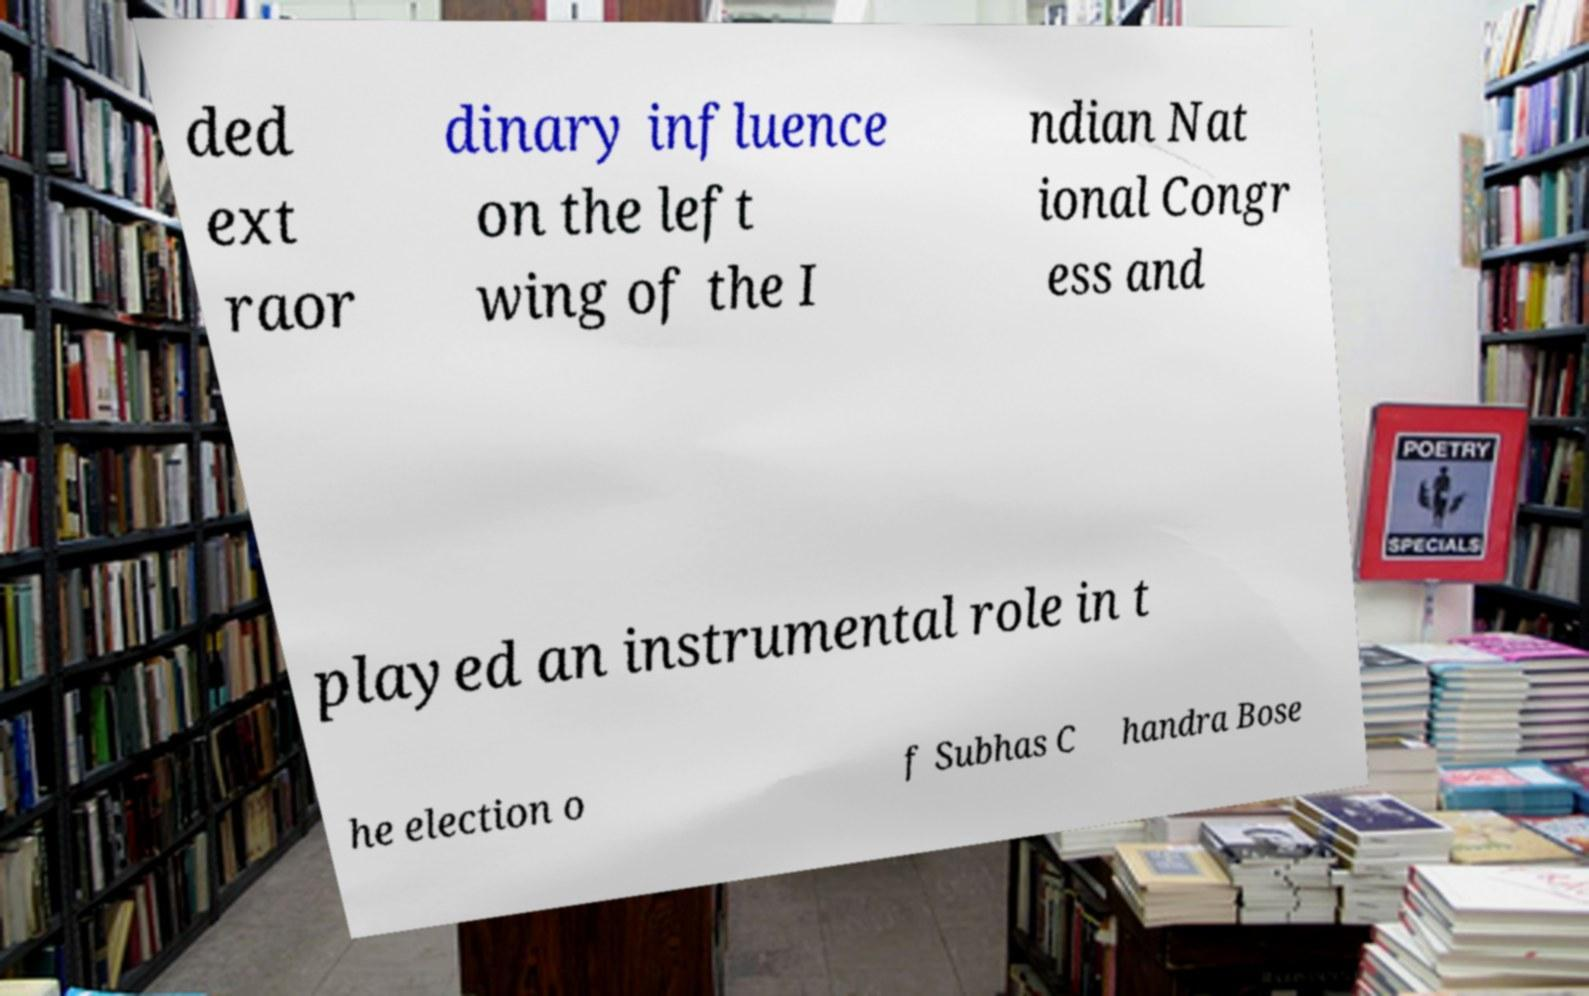Could you assist in decoding the text presented in this image and type it out clearly? ded ext raor dinary influence on the left wing of the I ndian Nat ional Congr ess and played an instrumental role in t he election o f Subhas C handra Bose 